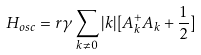<formula> <loc_0><loc_0><loc_500><loc_500>H _ { o s c } = r { \gamma } \sum _ { k { \neq } 0 } | k | [ A _ { k } ^ { + } A _ { k } + \frac { 1 } { 2 } ]</formula> 